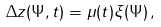Convert formula to latex. <formula><loc_0><loc_0><loc_500><loc_500>\Delta z ( \Psi , t ) = \mu ( t ) \xi ( \Psi ) \, ,</formula> 